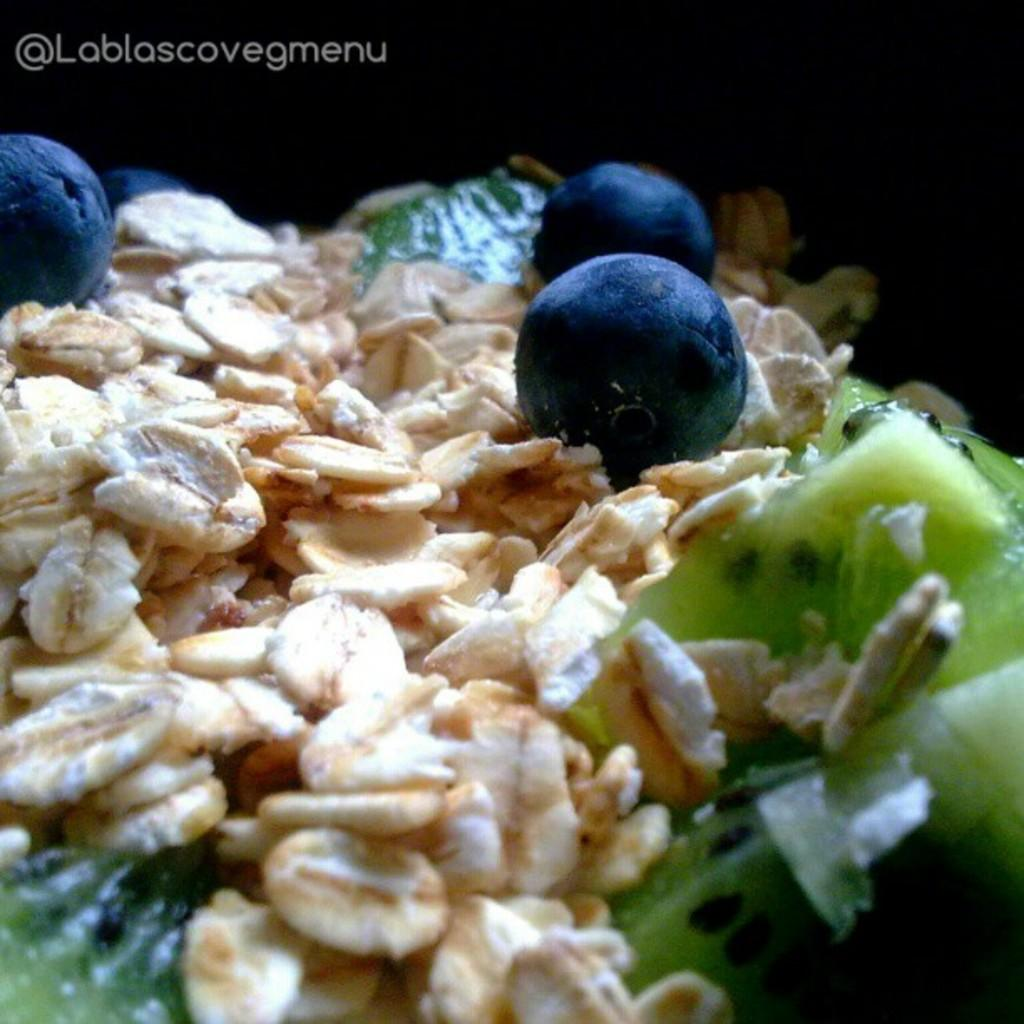What type of objects can be seen in the image? There are food items in the image. What can be observed about the background of the image? The background of the image is dark. Is there any text present in the image? Yes, there is some text in the top left corner of the image. How many babies are playing in the yard in the image? There are no babies or yards present in the image; it features food items and text on a dark background. 